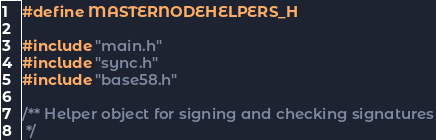Convert code to text. <code><loc_0><loc_0><loc_500><loc_500><_C_>#define MASTERNODEHELPERS_H

#include "main.h"
#include "sync.h"
#include "base58.h"

/** Helper object for signing and checking signatures
 */</code> 